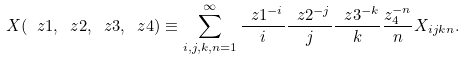Convert formula to latex. <formula><loc_0><loc_0><loc_500><loc_500>X ( \ z 1 , \ z 2 , \ z 3 , \ z 4 ) \equiv \sum _ { i , j , k , n = 1 } ^ { \infty } \frac { \ z 1 ^ { - i } } { i } \frac { \ z 2 ^ { - j } } { j } \frac { \ z 3 ^ { - k } } { k } \frac { z _ { 4 } ^ { - n } } { n } X _ { i j k n } .</formula> 